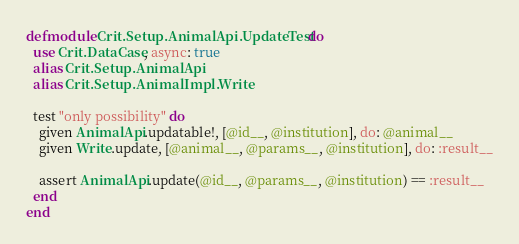Convert code to text. <code><loc_0><loc_0><loc_500><loc_500><_Elixir_>defmodule Crit.Setup.AnimalApi.UpdateTest do
  use Crit.DataCase, async: true
  alias Crit.Setup.AnimalApi
  alias Crit.Setup.AnimalImpl.Write

  test "only possibility" do
    given AnimalApi.updatable!, [@id__, @institution], do: @animal__
    given Write.update, [@animal__, @params__, @institution], do: :result__
    
    assert AnimalApi.update(@id__, @params__, @institution) == :result__
  end
end
</code> 